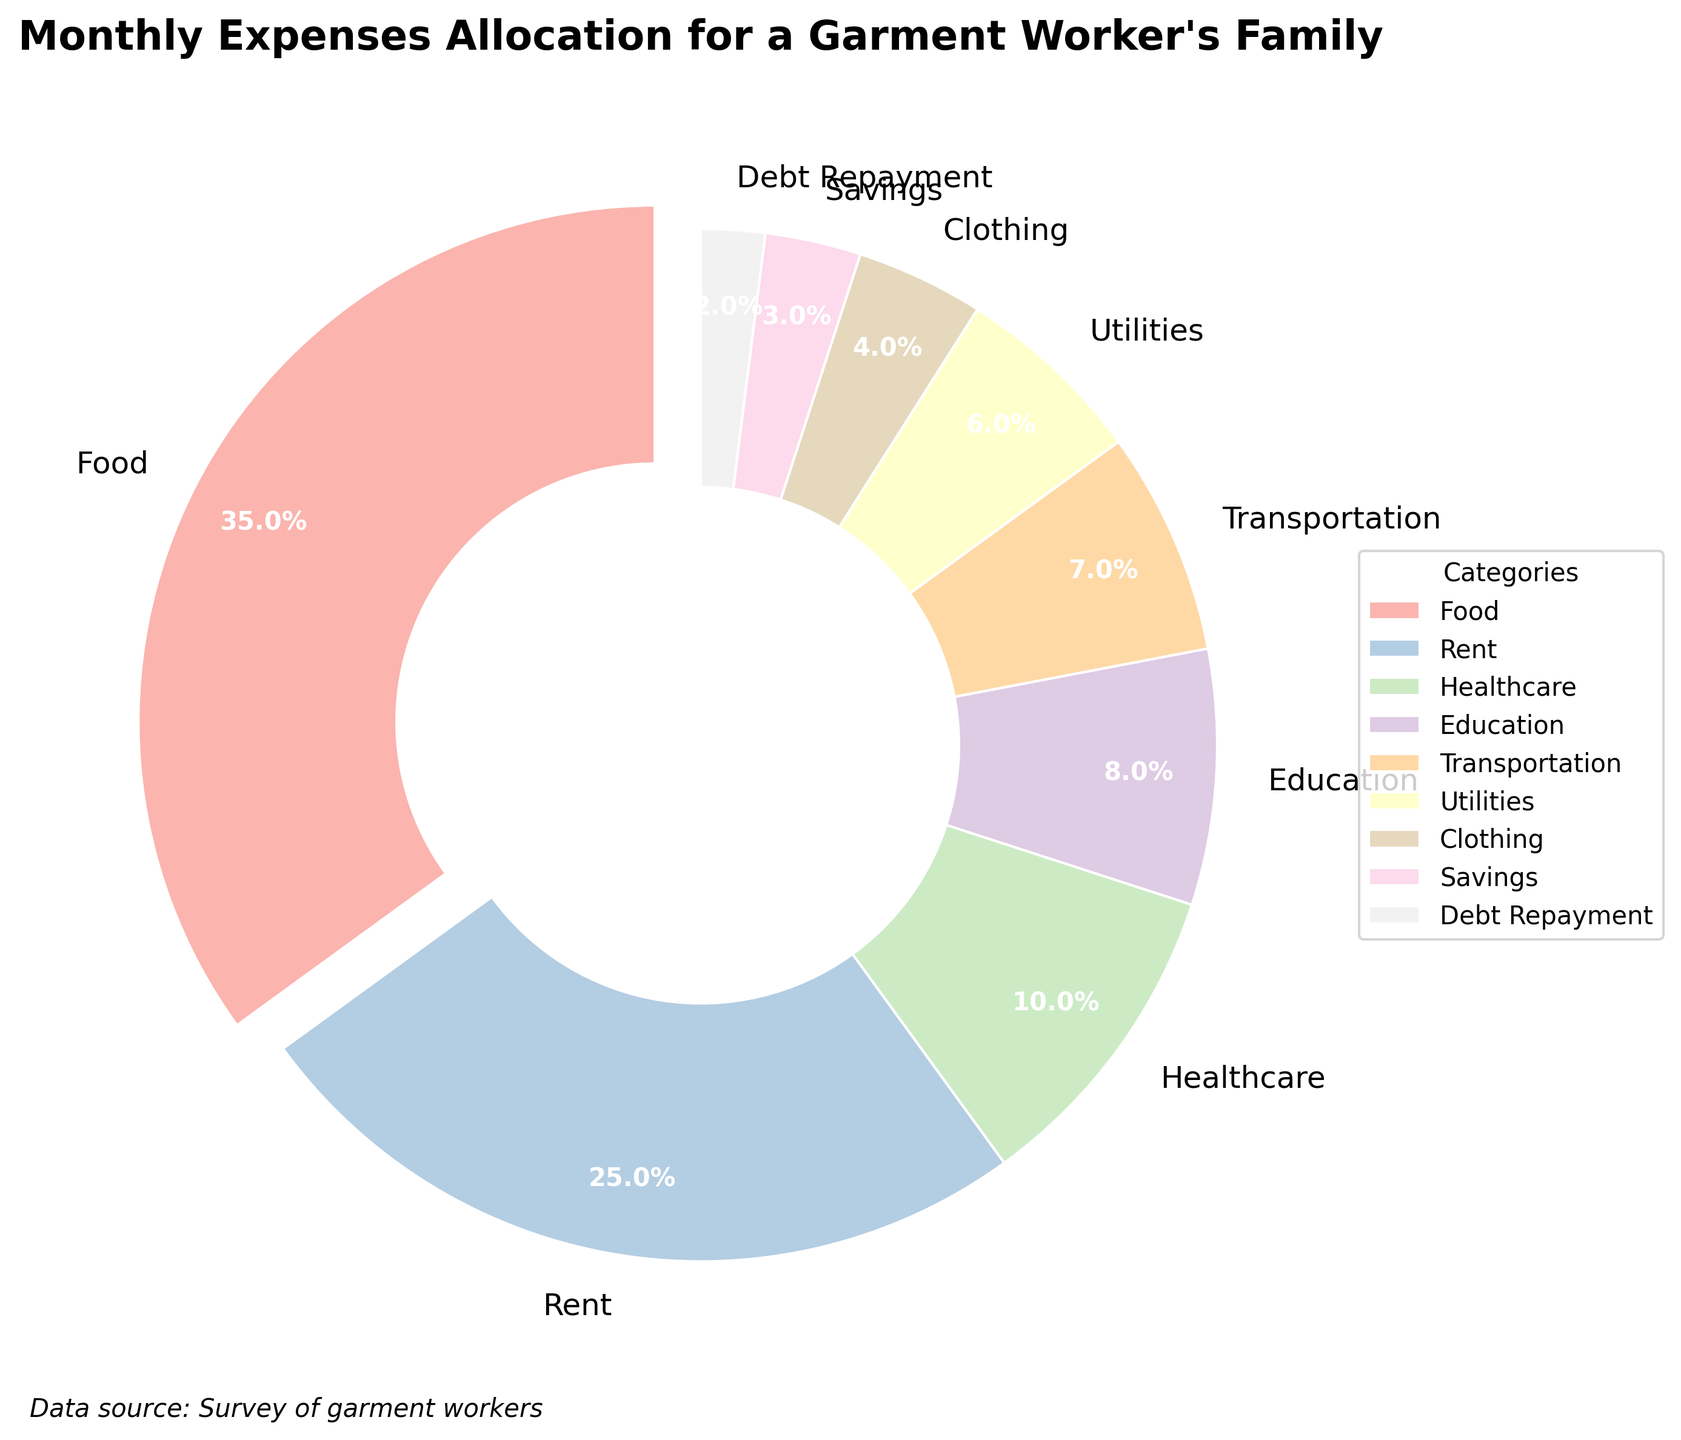What percentage of the total expenses is allocated to food? The pie chart shows the percentage of total expenses allocated to different categories for a typical garment worker's family. According to the chart, food expenses take up 35% of the total monthly expenses.
Answer: 35% What is the combined percentage allocated to transportation and utilities? To find the combined percentage of transportation and utilities, add the two percentages together. Transportation is 7% and utilities are 6%. So, 7% + 6% = 13%.
Answer: 13% Which category has the smallest allocation, and what is its percentage? By looking at the pie chart, Debt Repayment has the smallest allocation. The percentage allocated to Debt Repayment is 2%.
Answer: Debt Repayment, 2% How does the percentage allocated to healthcare compare to that allocated to education? The percentage allocated to healthcare is 10%, while education is allocated 8% of the expenses. Comparing these two, healthcare has a greater percentage than education.
Answer: Healthcare > Education What is the difference between the percentage allocations for rent and clothing? Rent is allocated 25% of the expenses, and clothing is allocated 4%. The difference between these two allocations is calculated by subtracting the smaller percentage (clothing) from the larger percentage (rent): 25% - 4% = 21%.
Answer: 21% If the percentages for food and savings were combined, would their total be greater than that for rent? Food is allocated 35% and savings 3%. Their combined total is 35% + 3% = 38%. Rent is allocated 25%. Since 38% is greater than 25%, the combined total of food and savings would be greater than the percentage for rent.
Answer: Yes Which category has the highest allocation, and how much more is it compared to the category with the second-highest allocation? The highest allocation is for food at 35%. The second-highest allocation is for rent at 25%. The difference between these two is 35% - 25% = 10%.
Answer: Food, 10% What percentage of the expenses is allocated to categories other than food and rent? First, add the percentages for food and rent: 35% (food) + 25% (rent) = 60%. Then subtract this sum from 100% to find the combined percentage for the other categories: 100% - 60% = 40%.
Answer: 40% List the categories in descending order based on their percentage allocation. The pie chart shows the following percentages for each category: Food (35%), Rent (25%), Healthcare (10%), Education (8%), Transportation (7%), Utilities (6%), Clothing (4%), Savings (3%), Debt Repayment (2%). In descending order, the categories are: Food, Rent, Healthcare, Education, Transportation, Utilities, Clothing, Savings, Debt Repayment.
Answer: Food, Rent, Healthcare, Education, Transportation, Utilities, Clothing, Savings, Debt Repayment 